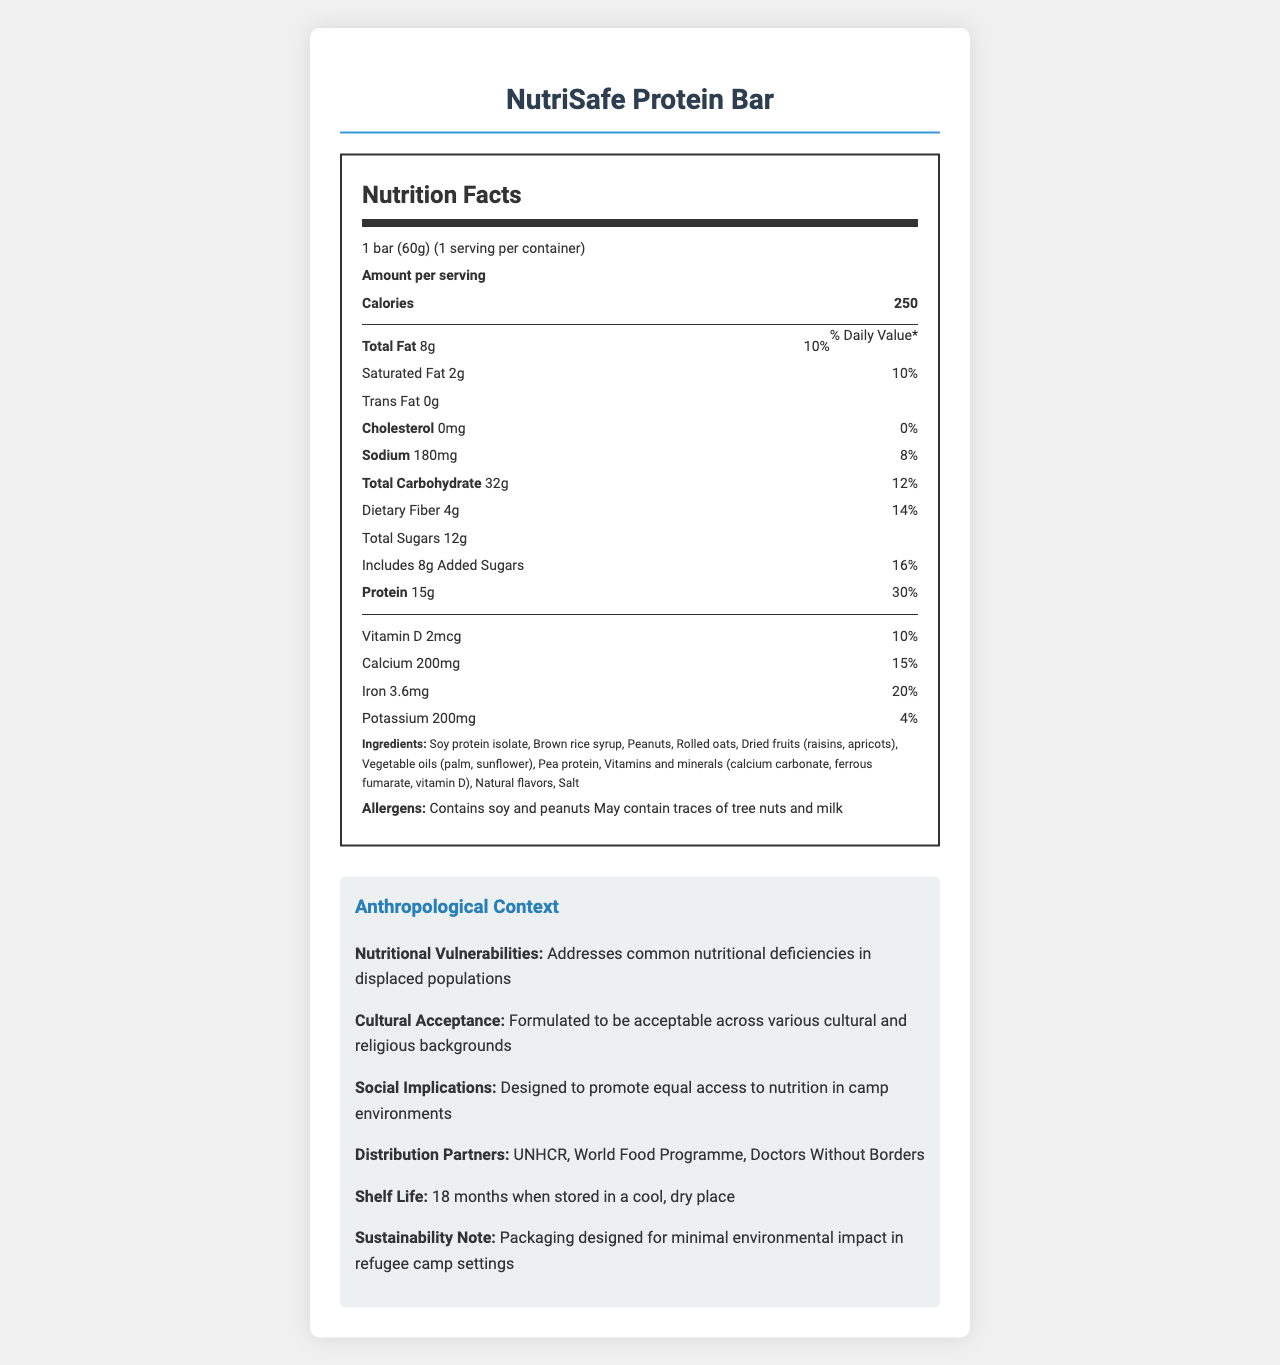what is the serving size listed for NutriSafe Protein Bar? The serving size is clearly stated at the top of the Nutrition Facts section as "1 bar (60g)".
Answer: 1 bar (60g) what is the amount of protein per serving in NutriSafe Protein Bar? The nutrition label lists "Protein" with an amount of 15g per serving.
Answer: 15g how many grams of dietary fiber are in one NutriSafe Protein Bar? The label under "Dietary Fiber" shows that there are 4g of dietary fiber per serving.
Answer: 4g What percent of the daily value is the calcium content? The label lists "Calcium" with a daily value percent of 15%.
Answer: 15% does NutriSafe Protein Bar contain trans fat? The label explicitly indicates "Trans Fat 0g," so it contains no trans fat.
Answer: No what allergens are mentioned on the label? The allergens section lists soy and peanuts as definite ingredients and mentions potential traces of tree nuts and milk.
Answer: Contains soy and peanuts, May contain traces of tree nuts and milk where is the manufacturer of NutriSafe Protein Bar located? The manufacturer information at the bottom of the document states the location as "Geneva, Switzerland".
Answer: Geneva, Switzerland which organization is NOT listed as a distribution partner for NutriSafe Protein Bar? A. UNHCR B. World Food Programme C. UNICEF D. Doctors Without Borders The distribution partners are listed as UNHCR, World Food Programme, and Doctors Without Borders. UNICEF is not mentioned.
Answer: C. UNICEF what is the total amount of sugars in NutriSafe Protein Bar? A. 4g B. 8g C. 12g D. 16g The label states "Total Sugars 12g," including added sugars.
Answer: C. 12g are NutriSafe Protein Bars vegetarian? The "nutritional considerations" section explicitly lists the product as vegetarian.
Answer: Yes describe the main purpose of the NutriSafe Protein Bar document. The document details the nutritional content, ingredients, allergens, and anthropological aspects, focusing on the bar's use in refugee camps and its cultural and social considerations.
Answer: The document provides comprehensive nutritional information, ingredient details, allergen information, and anthropological context for understanding the NutriSafe Protein Bar, which is distributed commonly in refugee camps to address nutritional deficiencies and cultural acceptance. how does the NutriSafe Protein Bar address nutritional vulnerabilities? The section under "Anthropological Context" states that the product is designed to address common nutritional deficiencies in displaced populations.
Answer: Provides key nutrients and addresses common deficiencies among displaced populations how should the NutriSafe Protein Bar be stored to maintain its shelf life? The document mentions an 18-month shelf life when stored in a cool, dry place.
Answer: In a cool, dry place what is the sustainability note for the NutriSafe Protein Bar's packaging? The sustainability note states that the packaging is designed for minimal environmental impact in refugee camp settings.
Answer: Packaging designed for minimal environmental impact in refugee camp settings which vitamin is included in the NutriSafe Protein Bar to contribute to 10% of the daily value? A. Vitamin A B. Vitamin C C. Vitamin E D. Vitamin D The label shows "Vitamin D 2mcg" with a daily value percent of 10%.
Answer: D. Vitamin D what is the protein source for NutriSafe Protein Bar? The ingredients list includes soy protein isolate and pea protein as protein sources.
Answer: Soy protein isolate and Pea protein how much potassium is in one NutriSafe Protein Bar? The nutrition label lists "Potassium" with an amount of 200mg.
Answer: 200mg what percentage of daily value of saturated fat is in one NutriSafe Protein Bar? The label indicates that the saturated fat percent daily value is 10%.
Answer: 10% what other countries produce the NutriSafe Protein Bar? The document only states that the manufacturer is located in Geneva, Switzerland, without mentioning any other production locations.
Answer: Cannot be determined 